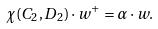Convert formula to latex. <formula><loc_0><loc_0><loc_500><loc_500>\chi ( C _ { 2 } , D _ { 2 } ) \cdot { w } ^ { + } = { \alpha } \cdot { w } .</formula> 